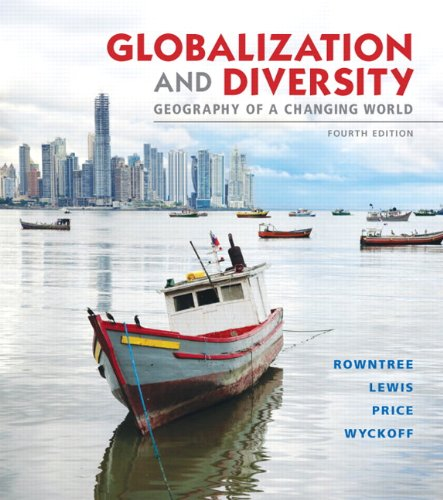Who is the author of this book?
Answer the question using a single word or phrase. Lester Rowntree What is the title of this book? Globalization and Diversity: Geography of a Changing World (4th Edition) What type of book is this? Science & Math Is this a fitness book? No 